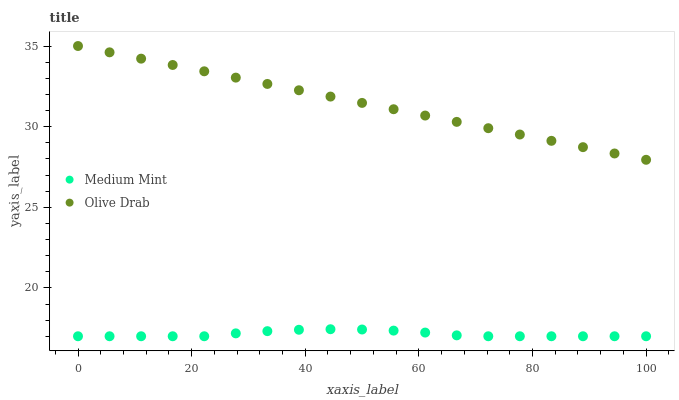Does Medium Mint have the minimum area under the curve?
Answer yes or no. Yes. Does Olive Drab have the maximum area under the curve?
Answer yes or no. Yes. Does Olive Drab have the minimum area under the curve?
Answer yes or no. No. Is Olive Drab the smoothest?
Answer yes or no. Yes. Is Medium Mint the roughest?
Answer yes or no. Yes. Is Olive Drab the roughest?
Answer yes or no. No. Does Medium Mint have the lowest value?
Answer yes or no. Yes. Does Olive Drab have the lowest value?
Answer yes or no. No. Does Olive Drab have the highest value?
Answer yes or no. Yes. Is Medium Mint less than Olive Drab?
Answer yes or no. Yes. Is Olive Drab greater than Medium Mint?
Answer yes or no. Yes. Does Medium Mint intersect Olive Drab?
Answer yes or no. No. 